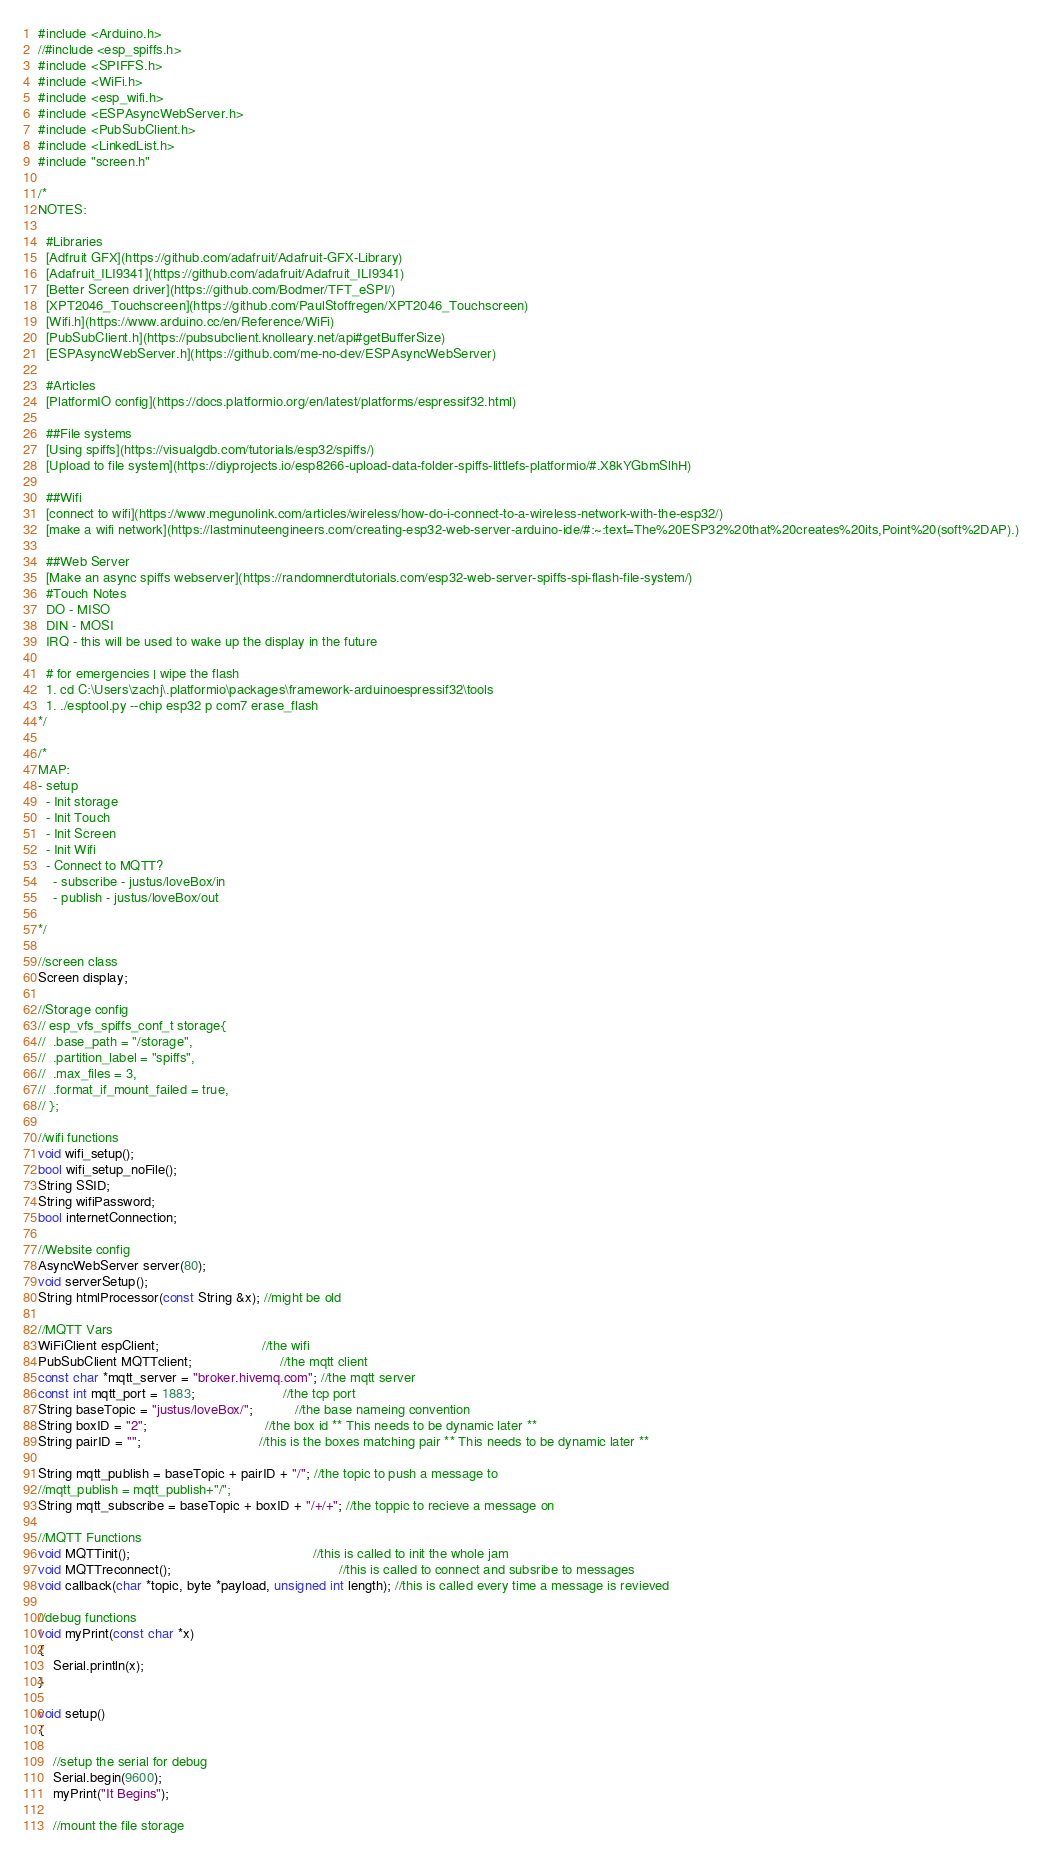<code> <loc_0><loc_0><loc_500><loc_500><_C++_>#include <Arduino.h>
//#include <esp_spiffs.h>
#include <SPIFFS.h>
#include <WiFi.h>
#include <esp_wifi.h>
#include <ESPAsyncWebServer.h>
#include <PubSubClient.h>
#include <LinkedList.h>
#include "screen.h"

/*
NOTES:

  #Libraries
  [Adfruit GFX](https://github.com/adafruit/Adafruit-GFX-Library)
  [Adafruit_ILI9341](https://github.com/adafruit/Adafruit_ILI9341)
  [Better Screen driver](https://github.com/Bodmer/TFT_eSPI/)
  [XPT2046_Touchscreen](https://github.com/PaulStoffregen/XPT2046_Touchscreen)
  [Wifi.h](https://www.arduino.cc/en/Reference/WiFi)
  [PubSubClient.h](https://pubsubclient.knolleary.net/api#getBufferSize)
  [ESPAsyncWebServer.h](https://github.com/me-no-dev/ESPAsyncWebServer)

  #Articles
  [PlatformIO config](https://docs.platformio.org/en/latest/platforms/espressif32.html)
  
  ##File systems
  [Using spiffs](https://visualgdb.com/tutorials/esp32/spiffs/)
  [Upload to file system](https://diyprojects.io/esp8266-upload-data-folder-spiffs-littlefs-platformio/#.X8kYGbmSlhH)

  ##Wifi
  [connect to wifi](https://www.megunolink.com/articles/wireless/how-do-i-connect-to-a-wireless-network-with-the-esp32/)
  [make a wifi network](https://lastminuteengineers.com/creating-esp32-web-server-arduino-ide/#:~:text=The%20ESP32%20that%20creates%20its,Point%20(soft%2DAP).)
  
  ##Web Server
  [Make an async spiffs webserver](https://randomnerdtutorials.com/esp32-web-server-spiffs-spi-flash-file-system/)
  #Touch Notes
  DO - MISO
  DIN - MOSI
  IRQ - this will be used to wake up the display in the future

  # for emergencies | wipe the flash
  1. cd C:\Users\zachj\.platformio\packages\framework-arduinoespressif32\tools
  1. ./esptool.py --chip esp32 p com7 erase_flash
*/

/*
MAP:
- setup
  - Init storage
  - Init Touch
  - Init Screen
  - Init Wifi
  - Connect to MQTT?
    - subscribe - justus/loveBox/in
    - publish - justus/loveBox/out

*/

//screen class
Screen display;

//Storage config
// esp_vfs_spiffs_conf_t storage{
// 	.base_path = "/storage",
// 	.partition_label = "spiffs",
// 	.max_files = 3,
// 	.format_if_mount_failed = true,
// };

//wifi functions
void wifi_setup();
bool wifi_setup_noFile();
String SSID;
String wifiPassword;
bool internetConnection;

//Website config
AsyncWebServer server(80);
void serverSetup();
String htmlProcessor(const String &x); //might be old

//MQTT Vars
WiFiClient espClient;						   //the wifi
PubSubClient MQTTclient;					   //the mqtt client
const char *mqtt_server = "broker.hivemq.com"; //the mqtt server
const int mqtt_port = 1883;					   //the tcp port
String baseTopic = "justus/loveBox/";		   //the base nameing convention
String boxID = "2";							   //the box id ** This needs to be dynamic later **
String pairID = "";							   //this is the boxes matching pair ** This needs to be dynamic later **

String mqtt_publish = baseTopic + pairID + "/"; //the topic to push a message to
//mqtt_publish = mqtt_publish+"/";
String mqtt_subscribe = baseTopic + boxID + "/+/+"; //the toppic to recieve a message on

//MQTT Functions
void MQTTinit();												//this is called to init the whole jam
void MQTTreconnect();											//this is called to connect and subsribe to messages
void callback(char *topic, byte *payload, unsigned int length); //this is called every time a message is revieved

//debug functions
void myPrint(const char *x)
{
	Serial.println(x);
}

void setup()
{

	//setup the serial for debug
	Serial.begin(9600);
	myPrint("It Begins");

	//mount the file storage</code> 